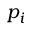<formula> <loc_0><loc_0><loc_500><loc_500>p _ { i }</formula> 